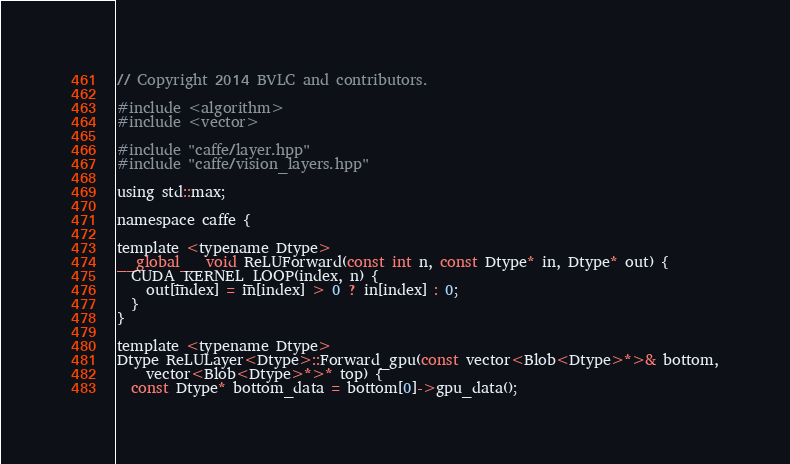Convert code to text. <code><loc_0><loc_0><loc_500><loc_500><_Cuda_>// Copyright 2014 BVLC and contributors.

#include <algorithm>
#include <vector>

#include "caffe/layer.hpp"
#include "caffe/vision_layers.hpp"

using std::max;

namespace caffe {

template <typename Dtype>
__global__ void ReLUForward(const int n, const Dtype* in, Dtype* out) {
  CUDA_KERNEL_LOOP(index, n) {
    out[index] = in[index] > 0 ? in[index] : 0;
  }
}

template <typename Dtype>
Dtype ReLULayer<Dtype>::Forward_gpu(const vector<Blob<Dtype>*>& bottom,
    vector<Blob<Dtype>*>* top) {
  const Dtype* bottom_data = bottom[0]->gpu_data();</code> 